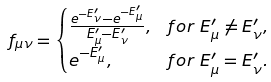Convert formula to latex. <formula><loc_0><loc_0><loc_500><loc_500>f _ { \mu \nu } & = \begin{cases} \frac { e ^ { - E ^ { \prime } _ { \nu } } - e ^ { - E ^ { \prime } _ { \mu } } } { E ^ { \prime } _ { \mu } - E ^ { \prime } _ { \nu } } , & f o r \ E ^ { \prime } _ { \mu } \neq E ^ { \prime } _ { \nu } , \\ e ^ { - E ^ { \prime } _ { \mu } } , & f o r \ E ^ { \prime } _ { \mu } = E ^ { \prime } _ { \nu } . \end{cases}</formula> 